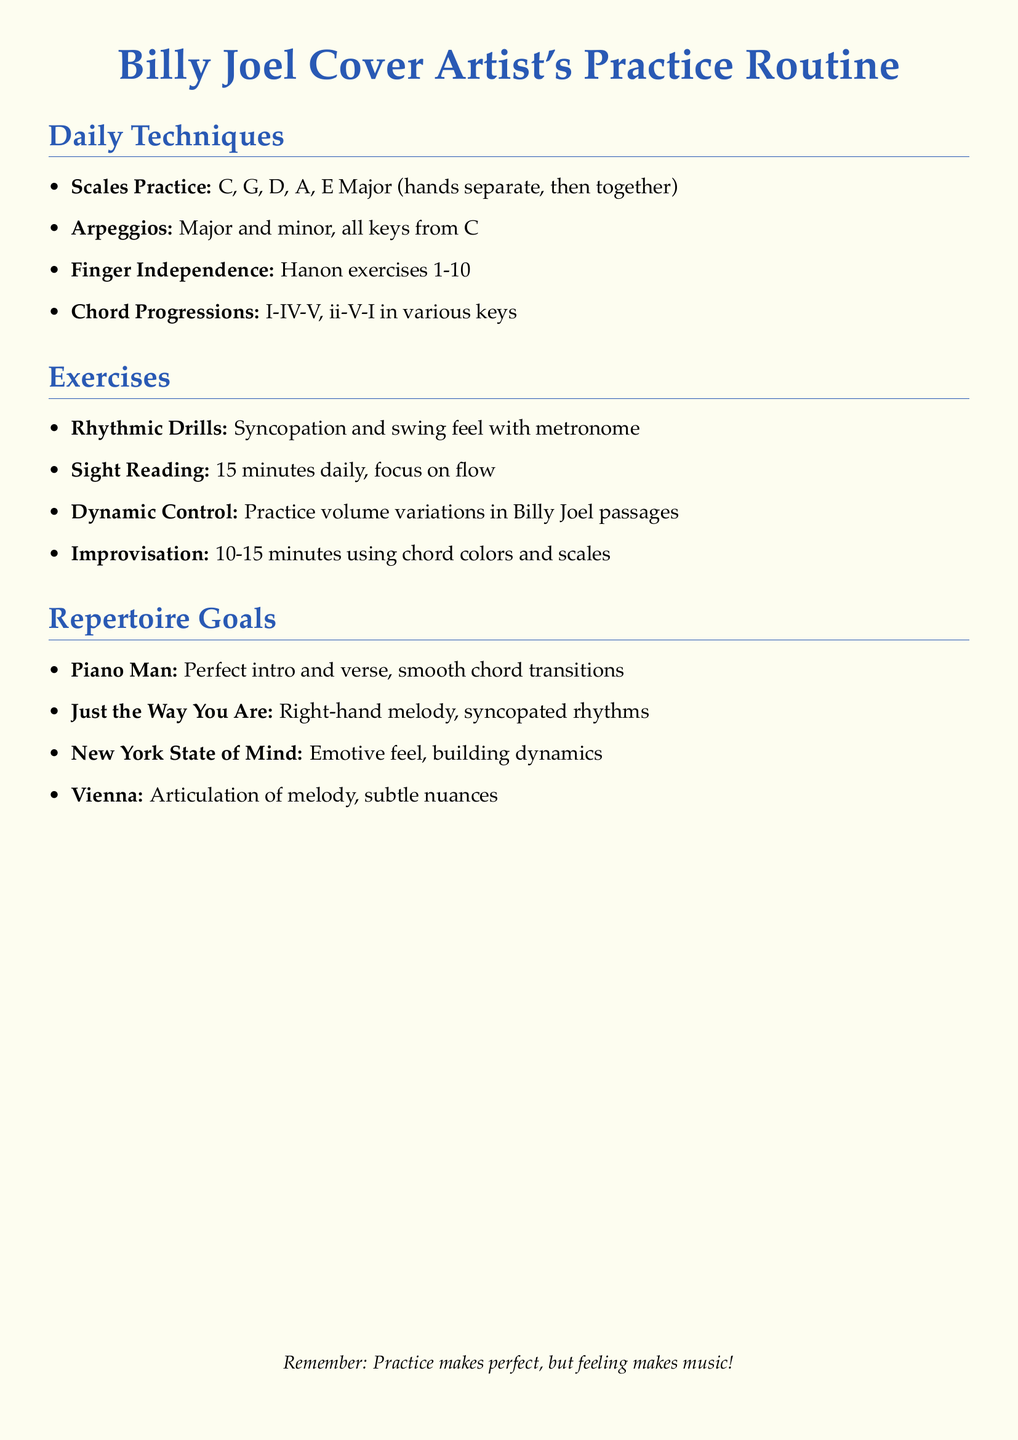What is the first song listed in the repertoire goals? The first song mentioned in the repertoire goals section is "Piano Man".
Answer: Piano Man How many minutes is recommended for sight reading daily? The document specifies 15 minutes for daily sight reading practice.
Answer: 15 minutes What type of exercises are included under finger independence? The exercises listed for finger independence are Hanon exercises 1-10.
Answer: Hanon exercises 1-10 Which rhythmic concept is practiced alongside the metronome? The rhythmic concept mentioned for practice with the metronome is syncopation and swing feel.
Answer: Syncopation and swing feel What is the primary goal related to "Just the Way You Are"? The primary goal mentioned for "Just the Way You Are" is focusing on the right-hand melody and syncopated rhythms.
Answer: Right-hand melody, syncopated rhythms How many major and minor arpeggios are practiced? The document states that major and minor arpeggios are practiced in all keys from C.
Answer: All keys from C What is the focus of the dynamic control exercise? The dynamic control exercise focuses on practicing volume variations in Billy Joel passages.
Answer: Volume variations What is the key message at the bottom of the document? The key message says, "Practice makes perfect, but feeling makes music!"
Answer: Practice makes perfect, but feeling makes music! 